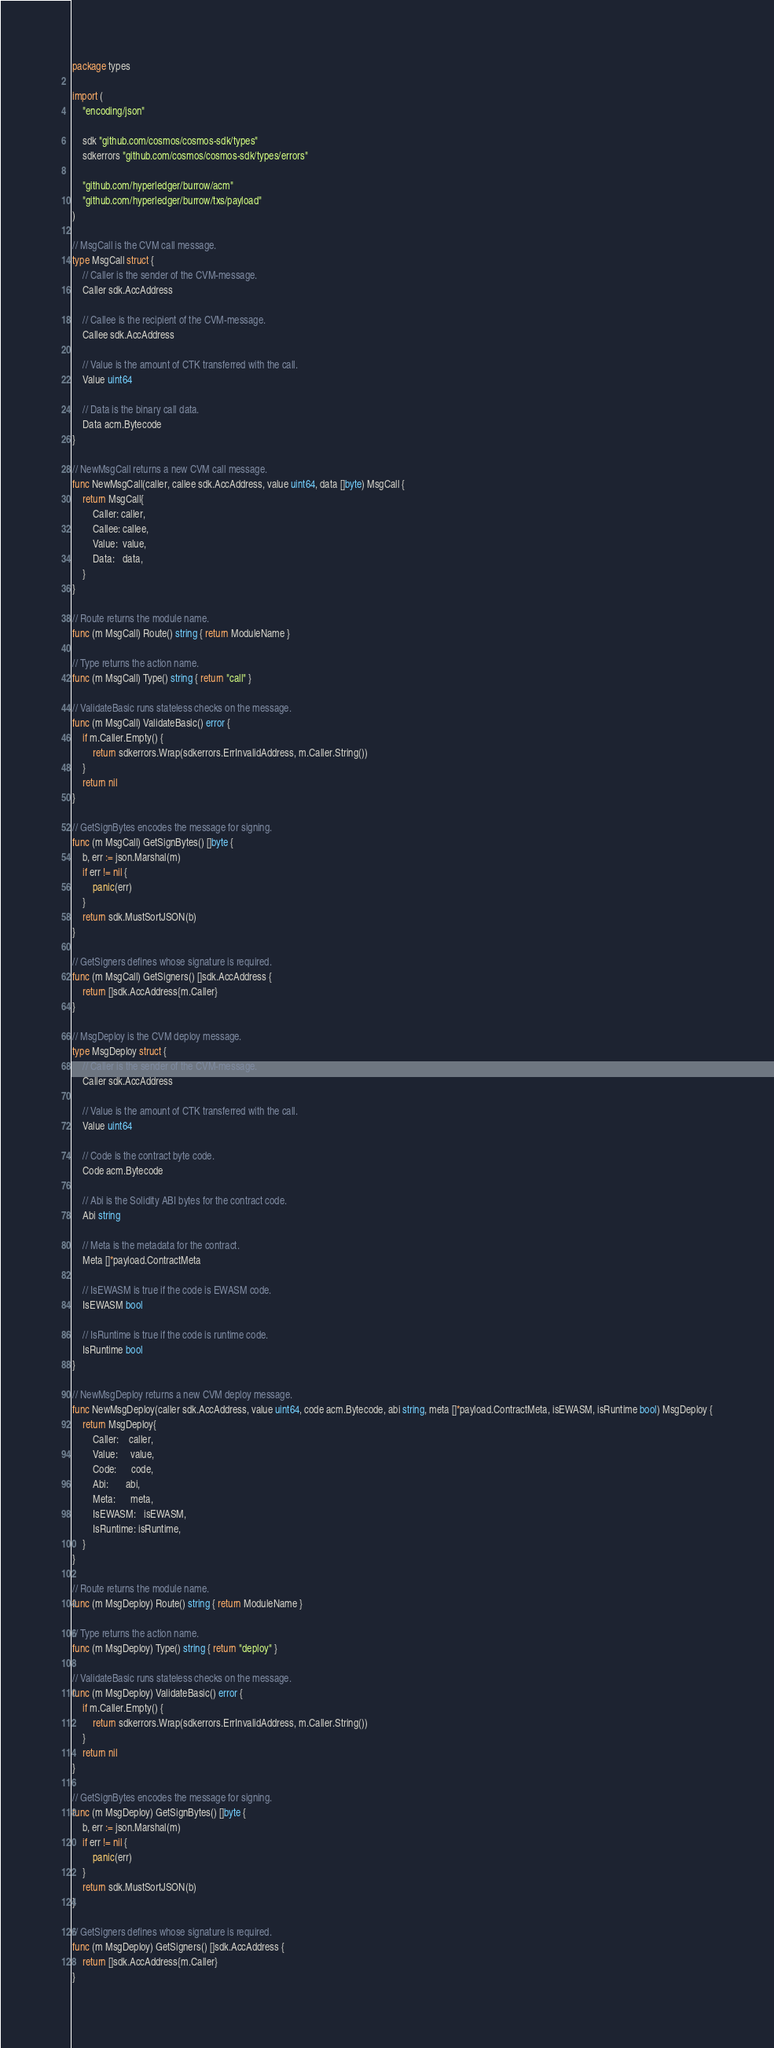<code> <loc_0><loc_0><loc_500><loc_500><_Go_>package types

import (
	"encoding/json"

	sdk "github.com/cosmos/cosmos-sdk/types"
	sdkerrors "github.com/cosmos/cosmos-sdk/types/errors"

	"github.com/hyperledger/burrow/acm"
	"github.com/hyperledger/burrow/txs/payload"
)

// MsgCall is the CVM call message.
type MsgCall struct {
	// Caller is the sender of the CVM-message.
	Caller sdk.AccAddress

	// Callee is the recipient of the CVM-message.
	Callee sdk.AccAddress

	// Value is the amount of CTK transferred with the call.
	Value uint64

	// Data is the binary call data.
	Data acm.Bytecode
}

// NewMsgCall returns a new CVM call message.
func NewMsgCall(caller, callee sdk.AccAddress, value uint64, data []byte) MsgCall {
	return MsgCall{
		Caller: caller,
		Callee: callee,
		Value:  value,
		Data:   data,
	}
}

// Route returns the module name.
func (m MsgCall) Route() string { return ModuleName }

// Type returns the action name.
func (m MsgCall) Type() string { return "call" }

// ValidateBasic runs stateless checks on the message.
func (m MsgCall) ValidateBasic() error {
	if m.Caller.Empty() {
		return sdkerrors.Wrap(sdkerrors.ErrInvalidAddress, m.Caller.String())
	}
	return nil
}

// GetSignBytes encodes the message for signing.
func (m MsgCall) GetSignBytes() []byte {
	b, err := json.Marshal(m)
	if err != nil {
		panic(err)
	}
	return sdk.MustSortJSON(b)
}

// GetSigners defines whose signature is required.
func (m MsgCall) GetSigners() []sdk.AccAddress {
	return []sdk.AccAddress{m.Caller}
}

// MsgDeploy is the CVM deploy message.
type MsgDeploy struct {
	// Caller is the sender of the CVM-message.
	Caller sdk.AccAddress

	// Value is the amount of CTK transferred with the call.
	Value uint64

	// Code is the contract byte code.
	Code acm.Bytecode

	// Abi is the Solidity ABI bytes for the contract code.
	Abi string

	// Meta is the metadata for the contract.
	Meta []*payload.ContractMeta

	// IsEWASM is true if the code is EWASM code.
	IsEWASM bool

	// IsRuntime is true if the code is runtime code.
	IsRuntime bool
}

// NewMsgDeploy returns a new CVM deploy message.
func NewMsgDeploy(caller sdk.AccAddress, value uint64, code acm.Bytecode, abi string, meta []*payload.ContractMeta, isEWASM, isRuntime bool) MsgDeploy {
	return MsgDeploy{
		Caller:    caller,
		Value:     value,
		Code:      code,
		Abi:       abi,
		Meta:      meta,
		IsEWASM:   isEWASM,
		IsRuntime: isRuntime,
	}
}

// Route returns the module name.
func (m MsgDeploy) Route() string { return ModuleName }

// Type returns the action name.
func (m MsgDeploy) Type() string { return "deploy" }

// ValidateBasic runs stateless checks on the message.
func (m MsgDeploy) ValidateBasic() error {
	if m.Caller.Empty() {
		return sdkerrors.Wrap(sdkerrors.ErrInvalidAddress, m.Caller.String())
	}
	return nil
}

// GetSignBytes encodes the message for signing.
func (m MsgDeploy) GetSignBytes() []byte {
	b, err := json.Marshal(m)
	if err != nil {
		panic(err)
	}
	return sdk.MustSortJSON(b)
}

// GetSigners defines whose signature is required.
func (m MsgDeploy) GetSigners() []sdk.AccAddress {
	return []sdk.AccAddress{m.Caller}
}
</code> 